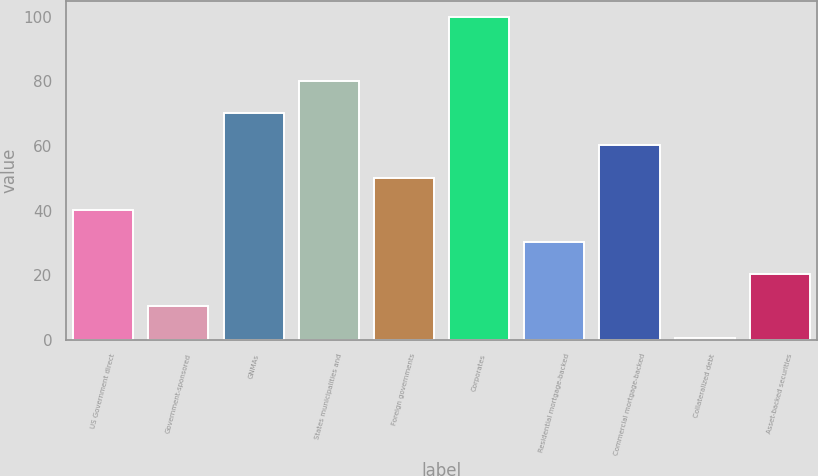Convert chart. <chart><loc_0><loc_0><loc_500><loc_500><bar_chart><fcel>US Government direct<fcel>Government-sponsored<fcel>GNMAs<fcel>States municipalities and<fcel>Foreign governments<fcel>Corporates<fcel>Residential mortgage-backed<fcel>Commercial mortgage-backed<fcel>Collateralized debt<fcel>Asset-backed securities<nl><fcel>40.27<fcel>10.4<fcel>70.14<fcel>80.09<fcel>50.23<fcel>100<fcel>30.31<fcel>60.18<fcel>0.45<fcel>20.36<nl></chart> 